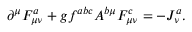Convert formula to latex. <formula><loc_0><loc_0><loc_500><loc_500>\partial ^ { \mu } F _ { \mu \nu } ^ { a } + g f ^ { a b c } A ^ { b \mu } F _ { \mu \nu } ^ { c } = - J _ { \nu } ^ { a } .</formula> 